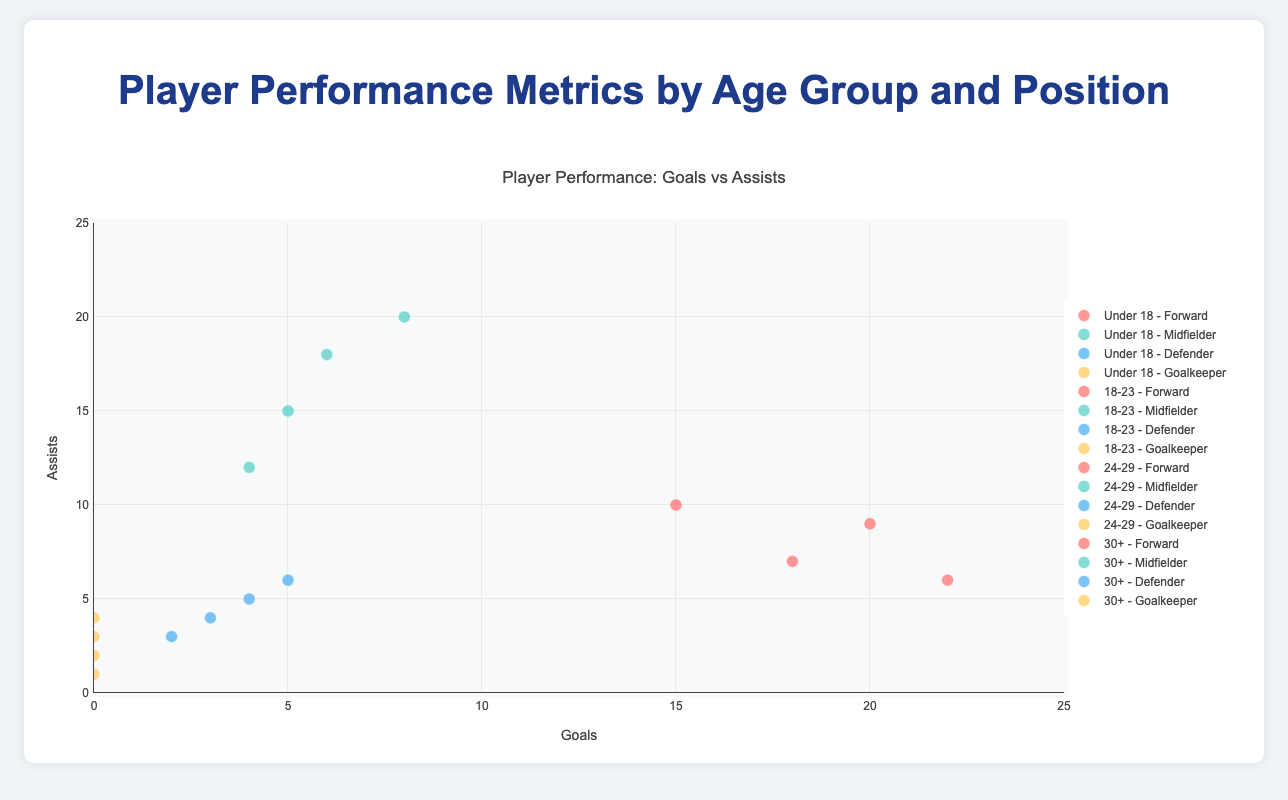What is the title of the chart? Look at the top of the chart where the title is displayed. The title usually provides an overview of what the chart is about.
Answer: Player Performance: Goals vs Assists Which age group has the highest goals for a forward position? Identify the markers or data points labeled "Under 18 - Forward", "18-23 - Forward", "24-29 - Forward", and "30+ - Forward". Then, compare the x-axis values (Goals) to find the highest one.
Answer: 30+ (Jorge Martinez with 22 goals) How many assists does Juan Lopez have? Hover over or identify the marker associated with Juan Lopez in the "Under 18 - Forward" group and read the value indicated for assists.
Answer: 10 Which player's marker is located at the highest point on the y-axis in the "24-29" age group? Locate the markers for the "24-29" age group and identify which one is at the top of the y-axis (Assists).
Answer: Pablo Sanchez Compare Juan Lopez and Raul Fernandez in terms of goals and assists. Who performs better in assists? Find Juan Lopez (Under 18 - Forward) and Raul Fernandez (30+ - Midfielder), and compare their assists values from the figure.
Answer: Raul Fernandez What is the Pass Accuracy for the midfielder with the most assists in the "18-23" age group? Identify who has the most assists within "18-23 - Midfielder" and check their information for Pass Accuracy from the hover text.
Answer: 87% (Sergio Gomez) How does the Pass Accuracy of midfielders change with age group? Compare the Pass Accuracy percentages for midfielders across different age groups: "Under 18", "18-23", "24-29", and "30+".
Answer: It increases with age: Under 18 (85%), 18-23 (87%), 24-29 (89%), 30+ (82%) Which goalkeepers have made more than 80 saves? Check the markers in the goalkeeper positions and refer to the hover text to see which goalkeepers have more than 80 saves.
Answer: Fernando Alvarez (85), Esteban Flores (95), Jose Morales (80) Which age group and position combination shows the least goals? Identify the combinations and compare the goals on the x-axis. The least goals would likely be where the x-axis values are closest to 0.
Answer: Goalkeepers across all age groups 